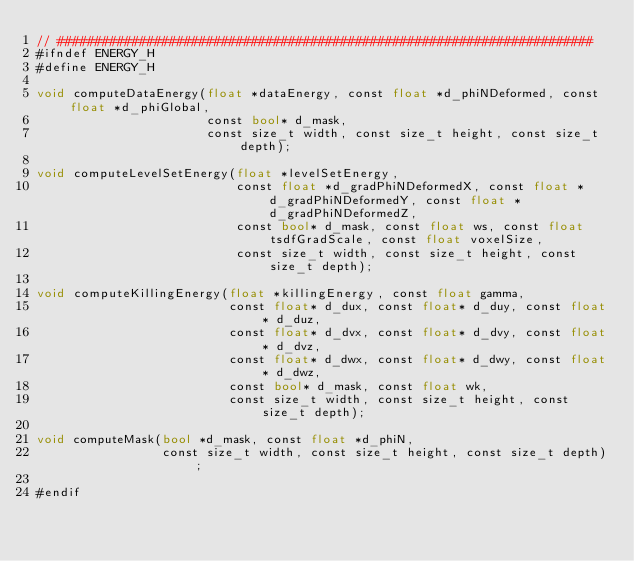Convert code to text. <code><loc_0><loc_0><loc_500><loc_500><_Cuda_>// ########################################################################
#ifndef ENERGY_H
#define ENERGY_H

void computeDataEnergy(float *dataEnergy, const float *d_phiNDeformed, const float *d_phiGlobal,
                       const bool* d_mask,
                       const size_t width, const size_t height, const size_t depth);

void computeLevelSetEnergy(float *levelSetEnergy,
                           const float *d_gradPhiNDeformedX, const float *d_gradPhiNDeformedY, const float *d_gradPhiNDeformedZ,
                           const bool* d_mask, const float ws, const float tsdfGradScale, const float voxelSize,
                           const size_t width, const size_t height, const size_t depth);

void computeKillingEnergy(float *killingEnergy, const float gamma,
                          const float* d_dux, const float* d_duy, const float* d_duz,
                          const float* d_dvx, const float* d_dvy, const float* d_dvz,
                          const float* d_dwx, const float* d_dwy, const float* d_dwz,
                          const bool* d_mask, const float wk,
                          const size_t width, const size_t height, const size_t depth);

void computeMask(bool *d_mask, const float *d_phiN,
                 const size_t width, const size_t height, const size_t depth);

#endif
</code> 